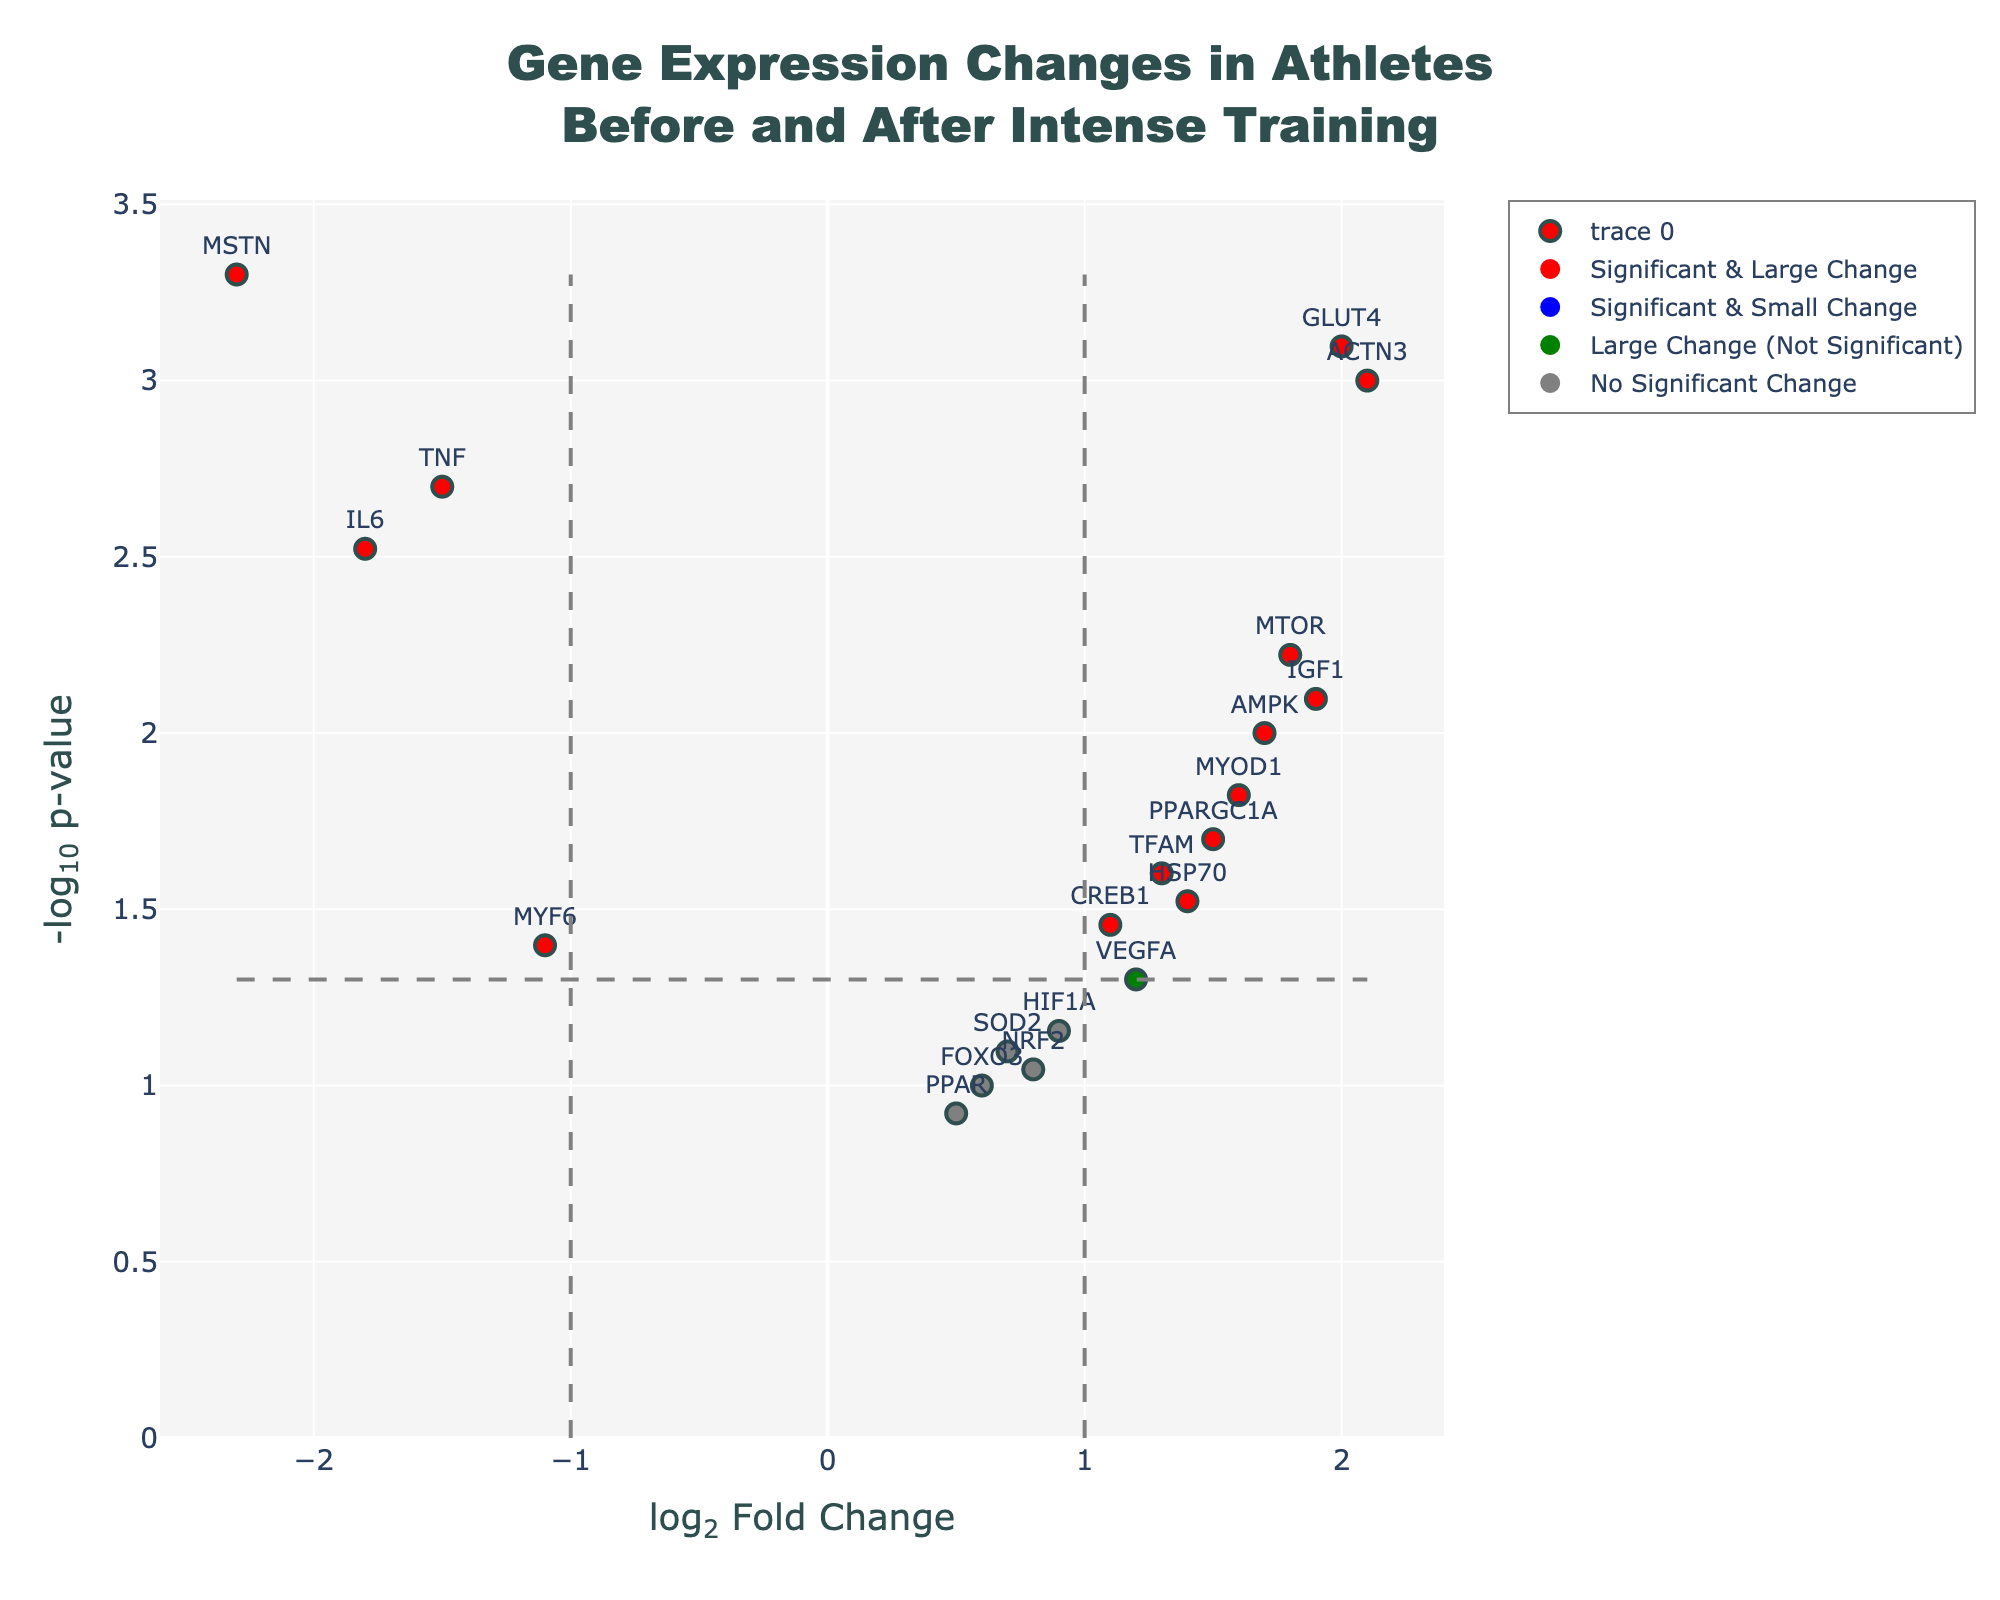What is the title of the figure? The title is displayed at the top of the figure and typically describes the main topic or subject of the plot. In this case, it says, "Gene Expression Changes in Athletes Before and After Intense Training."
Answer: Gene Expression Changes in Athletes Before and After Intense Training How many genes have a log2 fold change greater than 1 and a p-value less than 0.05? To determine the number of genes that meet these criteria, look for red points on the plot representing genes with significant and large changes.
Answer: 6 Which genes are shown as blue points on the plot? Blue points represent genes with significant changes but a log2 fold change less than or equal to 1. By locating blue points on the plot, we can identify the specific genes.
Answer: IL6, TNF What is the p-value threshold for significance in this plot? The p-value threshold is shown by a horizontal dashed line on the plot. The value can be determined by looking where this line intersects the y-axis.
Answer: 0.05 Which gene has the highest log2 fold change and p-value below 0.05? By examining the plot, look for the red point furthest to the right to identify the gene with the highest log2 fold change and a significant p-value.
Answer: ACTN3 How does the PPAR gene expression change compare to other genes in terms of significance and fold change? The PPAR gene is represented as a grey dot, indicating no significant change and a log2 fold change below 1. Compare its position relative to threshold lines and other genes.
Answer: Not significant, low fold change What is the most downregulated gene based on log2 fold change values? Downregulated genes will have negative log2 fold change values. The most downregulated gene will be the one furthest to the left on the plot.
Answer: MSTN How many genes have nonsignificant changes (p-value >= 0.05) and a log2 fold change greater than 1? Green points represent genes with large but nonsignificant changes. Count the number of green points on the plot.
Answer: 3 What is the significance and fold change of the AMPK gene? Locate the point labeled "AMPK" on the plot and note its position relative to both axes and thresholds to determine its significance and fold change.
Answer: Significant, fold change 1.7 Can you identify any genes with low fold change but high significance? Blue points represent low fold change but high significance. Look for points near the y-axis but above the horizontal threshold line.
Answer: IL6, TNF 